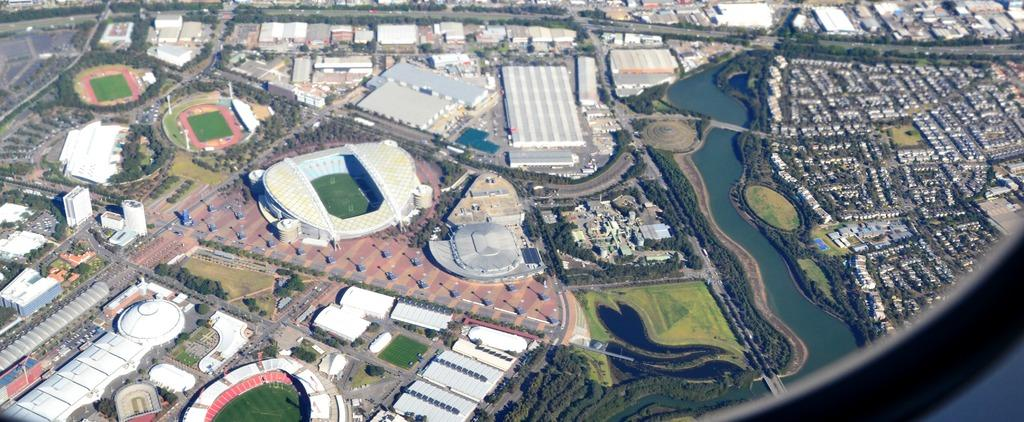What type of view is shown in the image? The image is an aerial view of a city. What structures can be seen in the image? There are buildings in the image. What type of vegetation is present in the image? There are trees, plants, and bushes in the image. Can you tell me how many wrens are perched on the buildings in the image? There are no wrens present in the image; it is an aerial view of a city with buildings and vegetation. Is there anyone skateboarding in the image? There is no indication of anyone skateboarding in the image; it is an aerial view of a city with buildings and vegetation. 